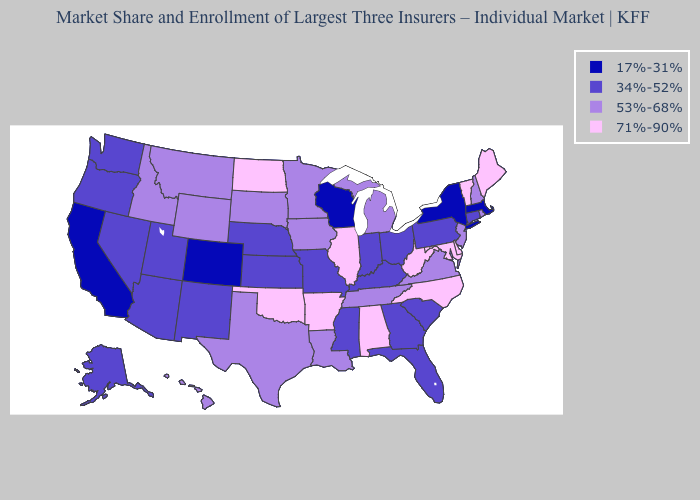What is the value of Florida?
Answer briefly. 34%-52%. Does Wisconsin have the lowest value in the USA?
Give a very brief answer. Yes. Does the first symbol in the legend represent the smallest category?
Concise answer only. Yes. What is the value of Texas?
Be succinct. 53%-68%. Name the states that have a value in the range 17%-31%?
Give a very brief answer. California, Colorado, Massachusetts, New York, Wisconsin. Name the states that have a value in the range 34%-52%?
Concise answer only. Alaska, Arizona, Connecticut, Florida, Georgia, Indiana, Kansas, Kentucky, Mississippi, Missouri, Nebraska, Nevada, New Mexico, Ohio, Oregon, Pennsylvania, South Carolina, Utah, Washington. What is the lowest value in the USA?
Give a very brief answer. 17%-31%. Does the map have missing data?
Quick response, please. No. Among the states that border Michigan , which have the highest value?
Be succinct. Indiana, Ohio. Does Maryland have the highest value in the South?
Quick response, please. Yes. What is the value of Pennsylvania?
Quick response, please. 34%-52%. Name the states that have a value in the range 71%-90%?
Quick response, please. Alabama, Arkansas, Delaware, Illinois, Maine, Maryland, North Carolina, North Dakota, Oklahoma, Vermont, West Virginia. Among the states that border South Carolina , which have the highest value?
Write a very short answer. North Carolina. Does Massachusetts have the highest value in the USA?
Answer briefly. No. Name the states that have a value in the range 71%-90%?
Short answer required. Alabama, Arkansas, Delaware, Illinois, Maine, Maryland, North Carolina, North Dakota, Oklahoma, Vermont, West Virginia. 